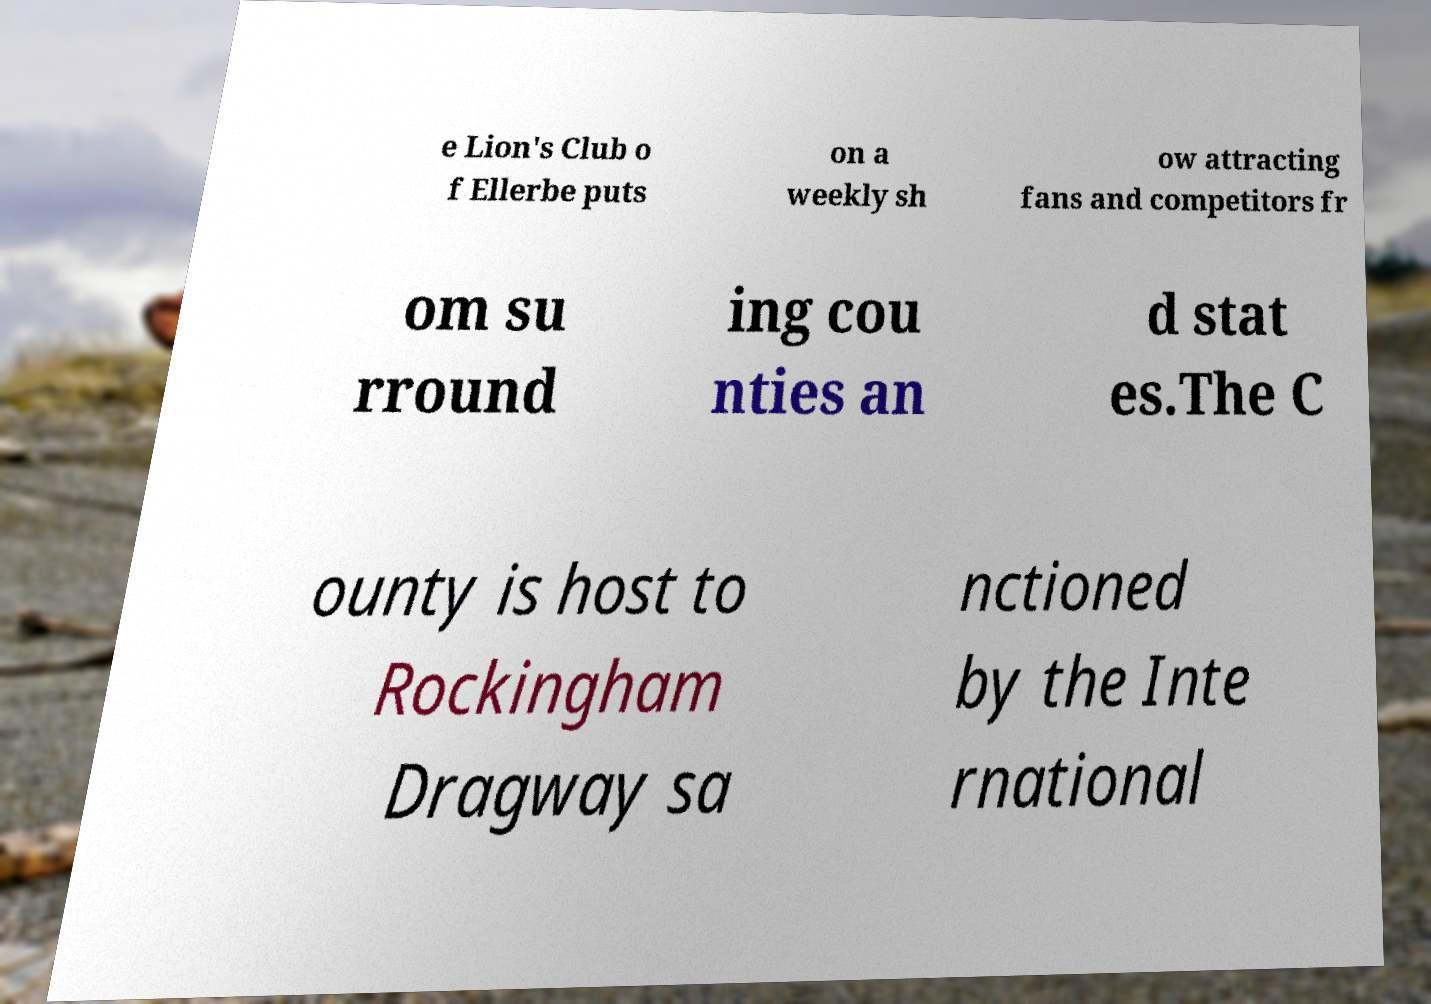Can you accurately transcribe the text from the provided image for me? e Lion's Club o f Ellerbe puts on a weekly sh ow attracting fans and competitors fr om su rround ing cou nties an d stat es.The C ounty is host to Rockingham Dragway sa nctioned by the Inte rnational 